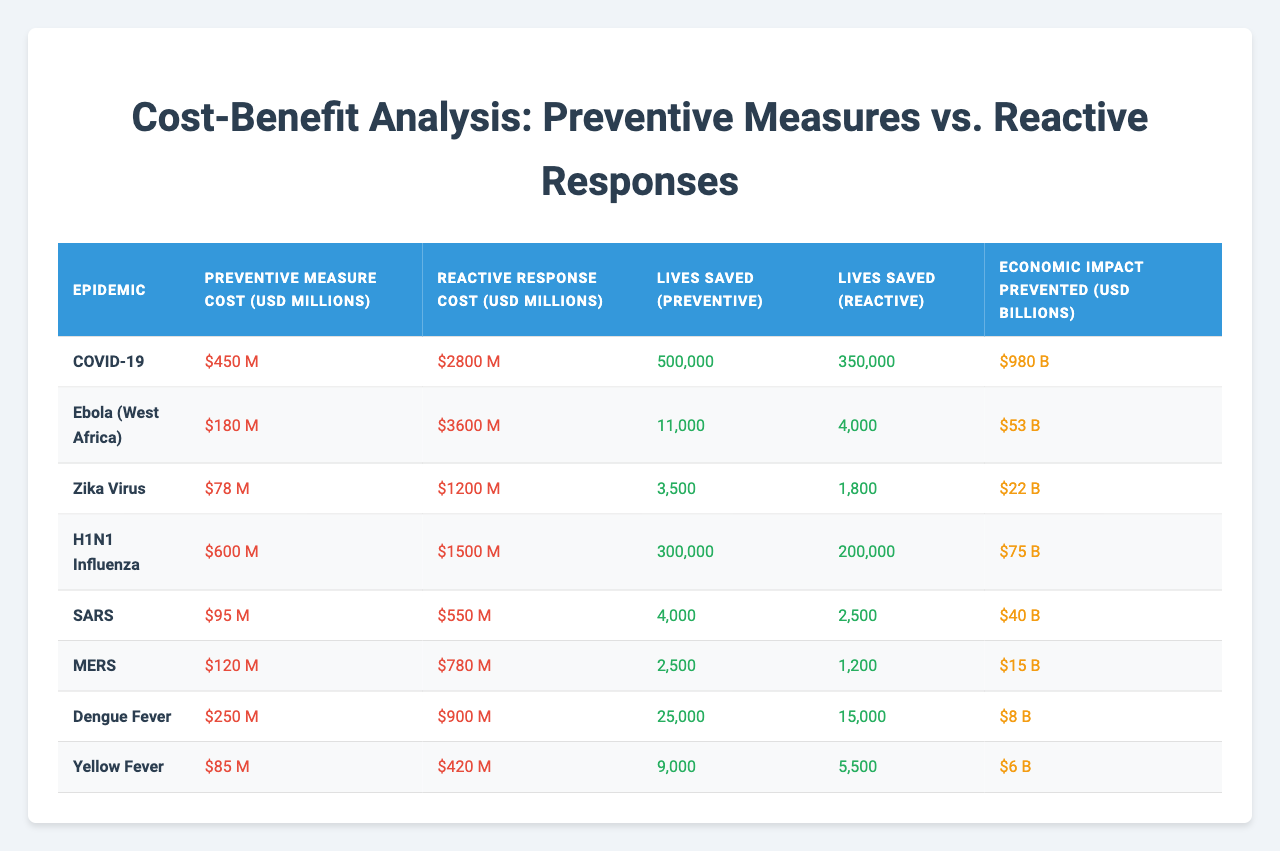What is the cost of preventive measures for the COVID-19 epidemic? The table shows a specific row for COVID-19 where the cost of preventive measures is listed as 450 million USD.
Answer: 450 million USD How many lives were saved through preventive measures in the Ebola outbreak? Referring to the Ebola row in the table, the lives saved through preventive measures are noted as 11,000.
Answer: 11,000 What is the total cost of reactive responses in the H1N1 Influenza outbreak? The H1N1 Influenza row indicates that the total cost of reactive responses is 1,500 million USD.
Answer: 1,500 million USD Which epidemic had the highest economic impact prevented from preventive measures? By comparing the "Economic Impact Prevented" column, we see COVID-19 has the highest value at 980 billion USD.
Answer: COVID-19 What is the difference between the lives saved by preventive measures and reactive responses in Zika Virus? For Zika Virus, lives saved by preventive measures is 3,500, and by reactive responses is 1,800. The difference is 3,500 - 1,800 = 1,700.
Answer: 1,700 Calculate the average cost of preventive measures across all epidemics listed. Adding the preventive measure costs (450 + 180 + 78 + 600 + 95 + 120 + 250 + 85) gives 1,858 million USD. There are 8 epidemics, so the average cost is 1,858 / 8 = 232.25 million USD.
Answer: 232.25 million USD Did the reactive responses for Dengue Fever cost more than for Yellow Fever? Looking at the table, the cost for Dengue Fever is 900 million USD and for Yellow Fever is 420 million USD. Since 900 > 420, the answer is yes.
Answer: Yes Which epidemic had the lowest cost for preventive measures and what was that cost? Upon reviewing the table, MERS has the lowest cost for preventive measures at 120 million USD.
Answer: 120 million USD How many more lives were saved through preventive measures in COVID-19 compared to MERS? Lives saved from preventive measures in COVID-19 is 500,000 and for MERS, it is 2,500. The difference is 500,000 - 2,500 = 497,500.
Answer: 497,500 Is the economic impact prevented by preventive measures for Ebola greater than 50 billion USD? The table shows that the economic impact prevented from preventive measures in the Ebola outbreak is 53 billion USD, which is indeed greater than 50 billion USD.
Answer: Yes 